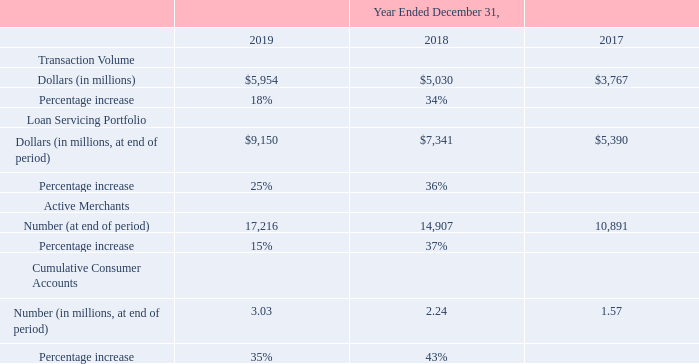ITEM 7. MANAGEMENT'S DISCUSSION AND ANALYSIS OF FINANCIAL CONDITION AND RESULTS OF OPERATIONS (United States Dollars in thousands, except per share data and unless otherwise indicated)
Business Metrics
We review a number of operating and financial metrics to evaluate our business, measure our performance, identify trends, formulate plans and make strategic decisions, including the following.
Transaction Volume. We define transaction volume as the dollar value of loans facilitated on our platform
during a given period. Transaction volume is an indicator of revenue and overall platform profitability and has
grown substantially in the past several years.
Loan Servicing Portfolio. We define our loan servicing portfolio as the aggregate outstanding consumer loan balance (principal plus accrued interest and fees) serviced by our platform at the date of measurement. Our loan servicing portfolio is an indicator of our servicing activities. The average loan servicing portfolio for the years ended December 31, 2019, 2018 and 2017 was $8,213 million, $6,303 million and $4,501 million, respectively.
Active Merchants. We define active merchants as home improvement merchants and healthcare providers that have submitted at least one consumer application during the twelve months ended at the date of measurement. Because our transaction volume is a function of the size, engagement and growth of our merchant network, active merchants, in aggregate, are an indicator of future revenue and profitability, although they are not directly correlated. The comparative measures can also be impacted by disciplined corrective action taken by the Company to remove merchants from our program who do not meet our customer satisfaction standards.
Cumulative Consumer Accounts. We define cumulative consumer accounts as the aggregate number of consumer accounts approved on our platform since our inception, including accounts with both outstanding and zero balances. Although not directly correlated to revenue, cumulative consumer accounts is a measure of our brand awareness among consumers, as well as the value of the data we have been collecting from such consumers since our inception. We may use this data to support future growth by cross-marketing products and delivering potential additional customers to merchants that may not have been able to source those customers themselves.
How did the company define Active Merchants? Home improvement merchants and healthcare providers that have submitted at least one consumer application during the twelve months ended at the date of measurement. How did the company define Loan Servicing Portfolio? The aggregate outstanding consumer loan balance (principal plus accrued interest and fees) serviced by our platform at the date of measurement. What was the transaction volume in 2019?
Answer scale should be: million. 5,954. How many years did the Transaction volume exceed $5,000 million? 2019##2018
Answer: 2. What was the change in the Loan Servicing Portfolio between 2017 and 2018?
Answer scale should be: million. 7,341-5,390
Answer: 1951. What was the percentage change in the Cumulative Consumer Accounts between 2017 and 2019?
Answer scale should be: percent. (3.03-1.57)/1.57
Answer: 92.99. 